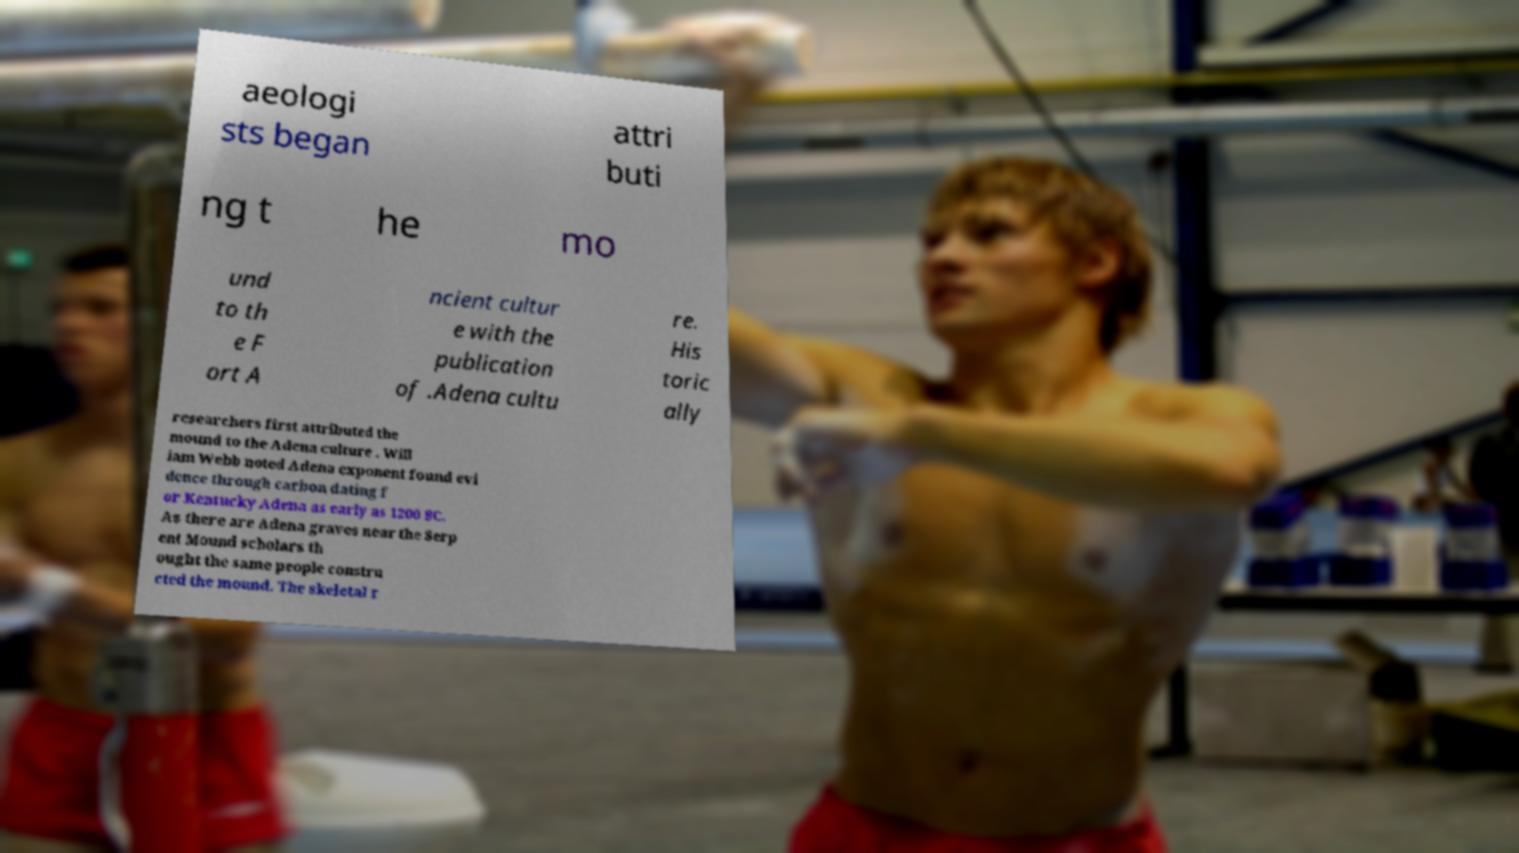What messages or text are displayed in this image? I need them in a readable, typed format. aeologi sts began attri buti ng t he mo und to th e F ort A ncient cultur e with the publication of .Adena cultu re. His toric ally researchers first attributed the mound to the Adena culture . Will iam Webb noted Adena exponent found evi dence through carbon dating f or Kentucky Adena as early as 1200 BC. As there are Adena graves near the Serp ent Mound scholars th ought the same people constru cted the mound. The skeletal r 